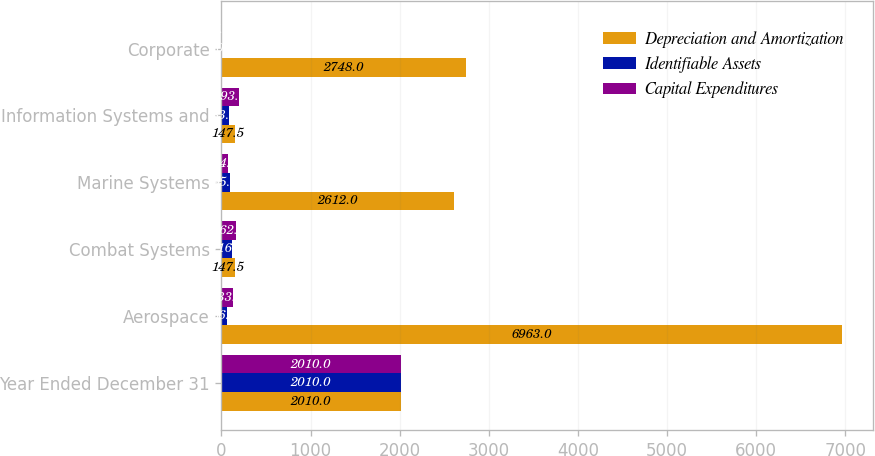Convert chart to OTSL. <chart><loc_0><loc_0><loc_500><loc_500><stacked_bar_chart><ecel><fcel>Year Ended December 31<fcel>Aerospace<fcel>Combat Systems<fcel>Marine Systems<fcel>Information Systems and<fcel>Corporate<nl><fcel>Depreciation and Amortization<fcel>2010<fcel>6963<fcel>147.5<fcel>2612<fcel>147.5<fcel>2748<nl><fcel>Identifiable Assets<fcel>2010<fcel>66<fcel>116<fcel>95<fcel>83<fcel>10<nl><fcel>Capital Expenditures<fcel>2010<fcel>133<fcel>162<fcel>74<fcel>193<fcel>7<nl></chart> 